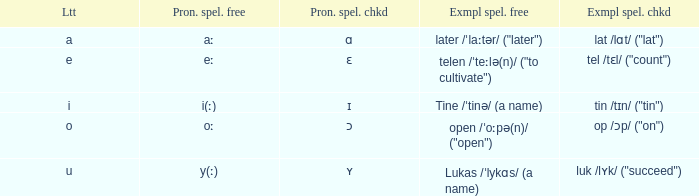When "tin /tɪn/ ("tin")" is given as the "example spelled checked," what is the interpretation of "letter"? I. 